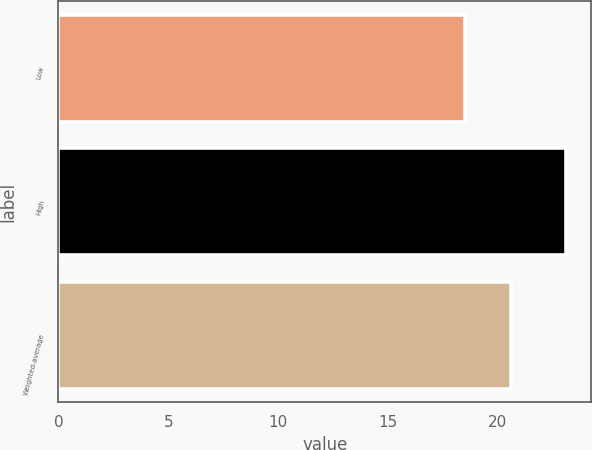<chart> <loc_0><loc_0><loc_500><loc_500><bar_chart><fcel>Low<fcel>High<fcel>Weighted-average<nl><fcel>18.5<fcel>23.1<fcel>20.6<nl></chart> 